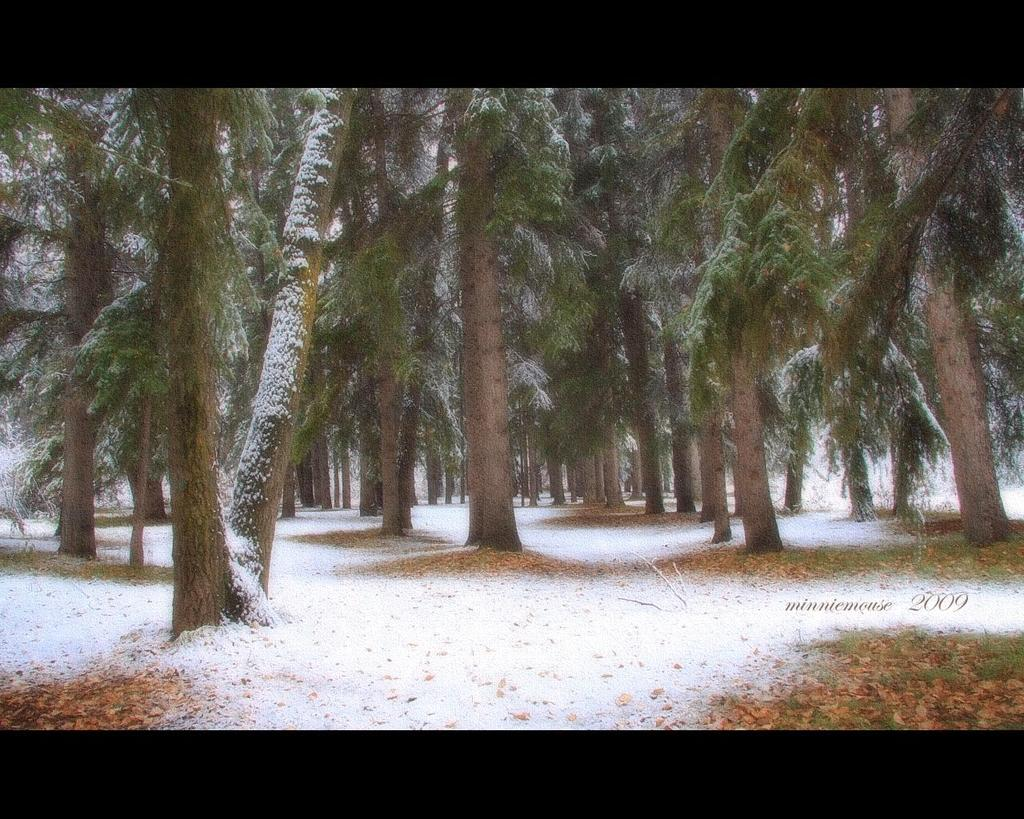What type of weather condition is depicted in the image? There is snow in the image, indicating a cold weather condition. What type of vegetation is present in the image? There is grass in the image, along with dried leaves. What type of natural structures are visible in the image? There are trees in the image. How does the snow rub against the trees in the image? The snow does not rub against the trees in the image; it simply covers the ground and other surfaces. 